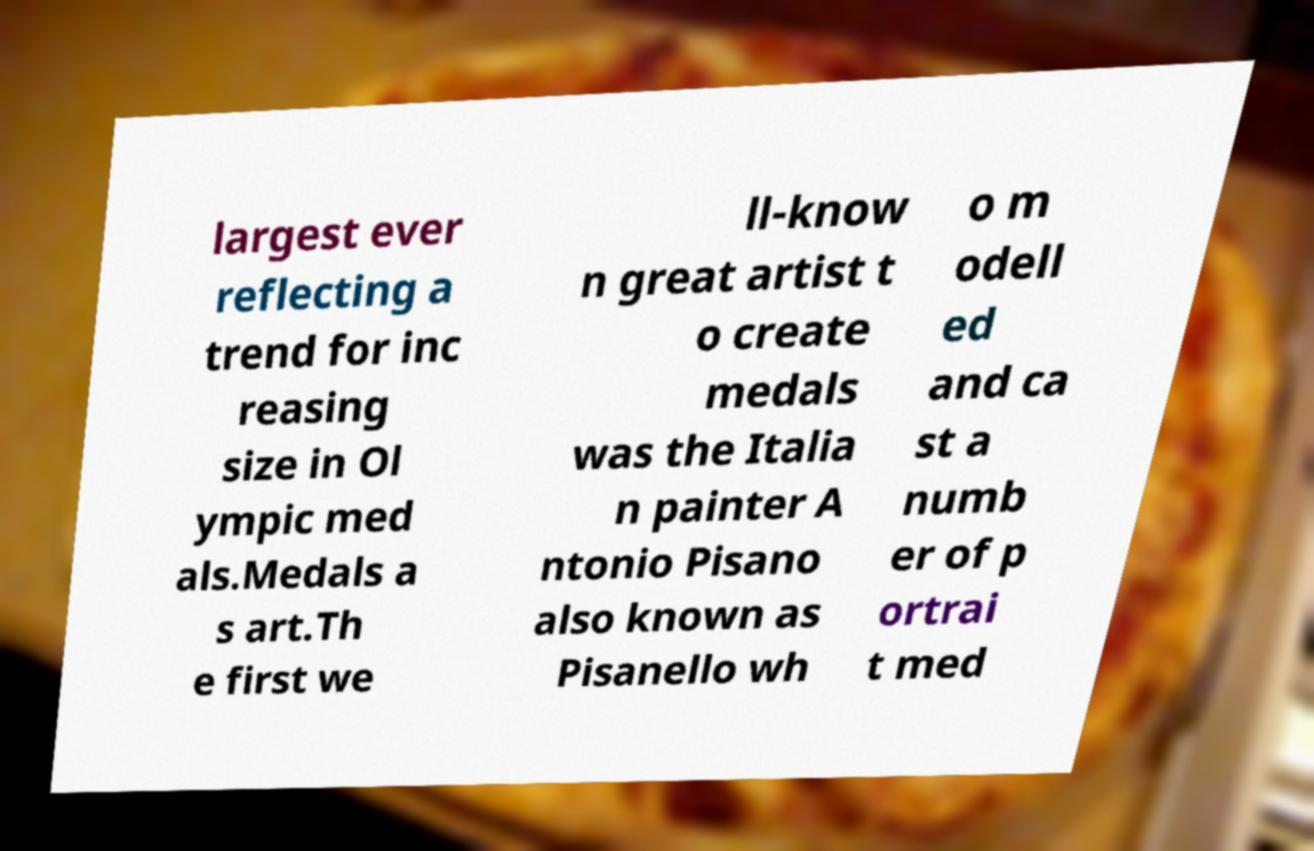Can you accurately transcribe the text from the provided image for me? largest ever reflecting a trend for inc reasing size in Ol ympic med als.Medals a s art.Th e first we ll-know n great artist t o create medals was the Italia n painter A ntonio Pisano also known as Pisanello wh o m odell ed and ca st a numb er of p ortrai t med 